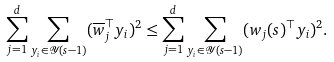<formula> <loc_0><loc_0><loc_500><loc_500>\sum _ { j = 1 } ^ { d } \sum _ { y _ { i } \in \mathcal { Y } ( s - 1 ) } ( \overline { w } _ { j } ^ { \top } y _ { i } ) ^ { 2 } \leq \sum _ { j = 1 } ^ { d } \sum _ { y _ { i } \in \mathcal { Y } ( s - 1 ) } ( w _ { j } ( s ) ^ { \top } y _ { i } ) ^ { 2 } .</formula> 